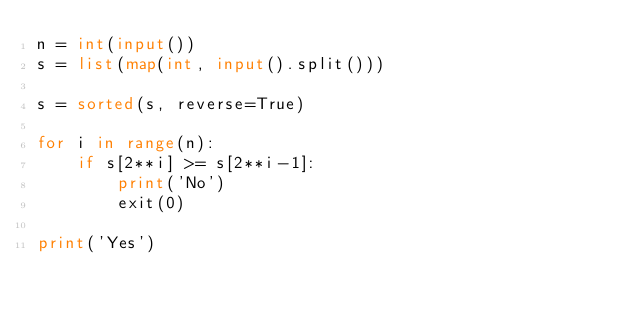Convert code to text. <code><loc_0><loc_0><loc_500><loc_500><_Python_>n = int(input())
s = list(map(int, input().split()))

s = sorted(s, reverse=True)

for i in range(n):
    if s[2**i] >= s[2**i-1]:
        print('No')
        exit(0)

print('Yes')</code> 